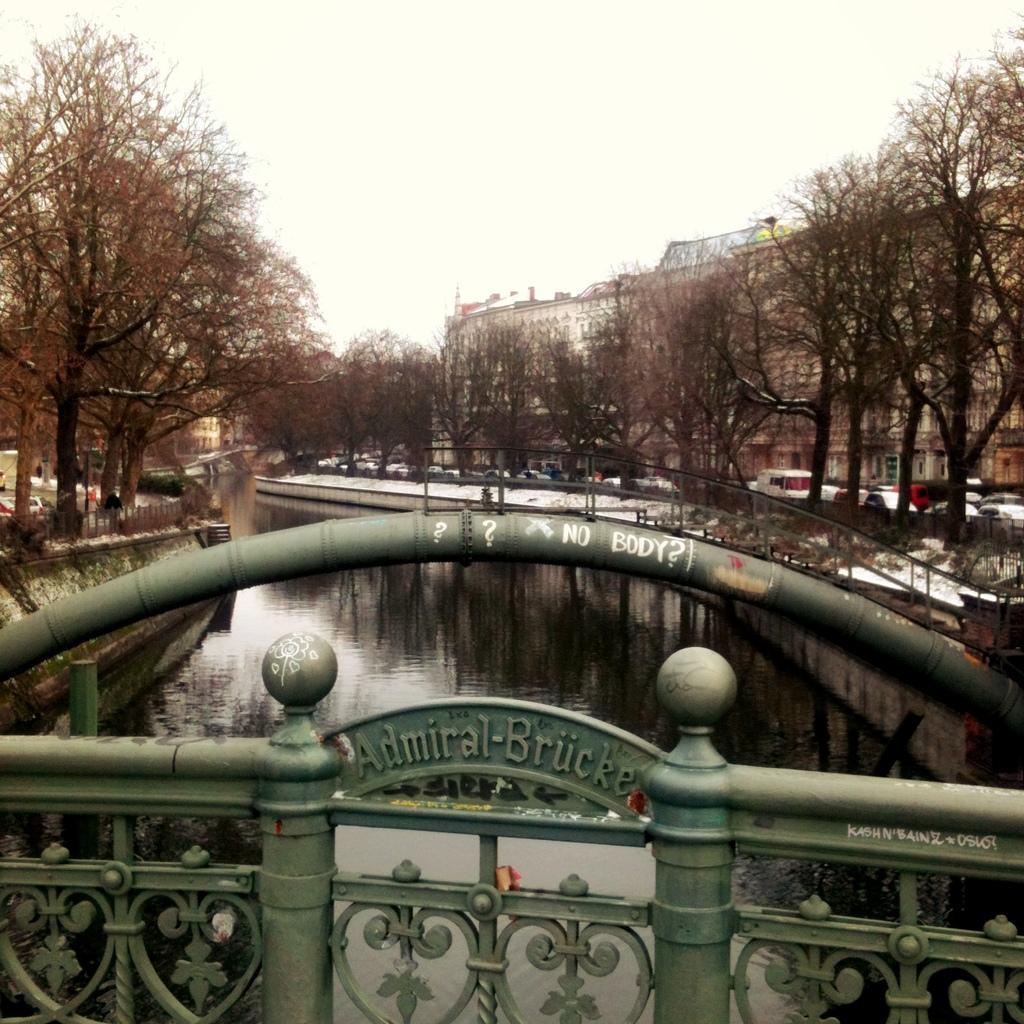How would you summarize this image in a sentence or two? In the front of the image there is a fencing. Something is written on the fencing. In the background of the image there are trees, vehicles, buildings, water, the sky and objects.   